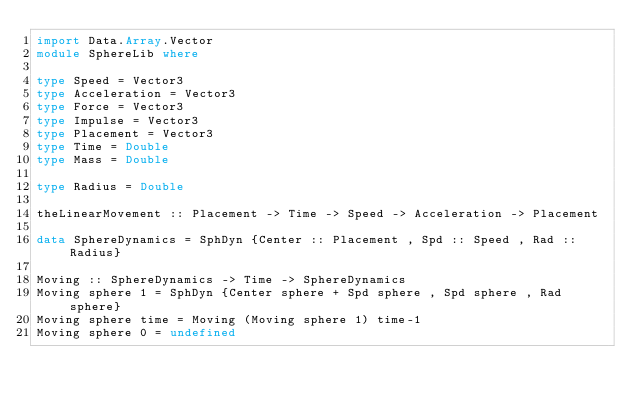<code> <loc_0><loc_0><loc_500><loc_500><_Haskell_>import Data.Array.Vector
module SphereLib where

type Speed = Vector3
type Acceleration = Vector3
type Force = Vector3
type Impulse = Vector3
type Placement = Vector3
type Time = Double
type Mass = Double

type Radius = Double

theLinearMovement :: Placement -> Time -> Speed -> Acceleration -> Placement

data SphereDynamics = SphDyn {Center :: Placement , Spd :: Speed , Rad :: Radius}

Moving :: SphereDynamics -> Time -> SphereDynamics
Moving sphere 1 = SphDyn {Center sphere + Spd sphere , Spd sphere , Rad sphere}
Moving sphere time = Moving (Moving sphere 1) time-1
Moving sphere 0 = undefined</code> 